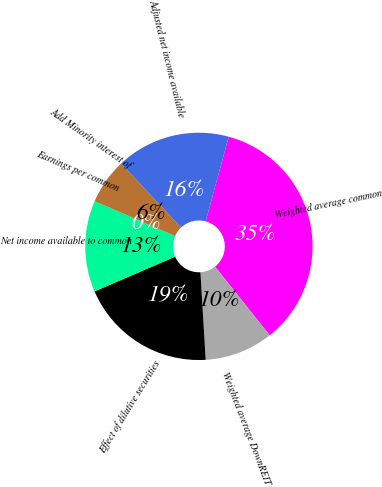<chart> <loc_0><loc_0><loc_500><loc_500><pie_chart><fcel>Weighted average common<fcel>Weighted average DownREIT<fcel>Effect of dilutive securities<fcel>Net income available to common<fcel>Earnings per common<fcel>Add Minority interest of<fcel>Adjusted net income available<nl><fcel>35.08%<fcel>9.74%<fcel>19.48%<fcel>12.98%<fcel>0.0%<fcel>6.49%<fcel>16.23%<nl></chart> 